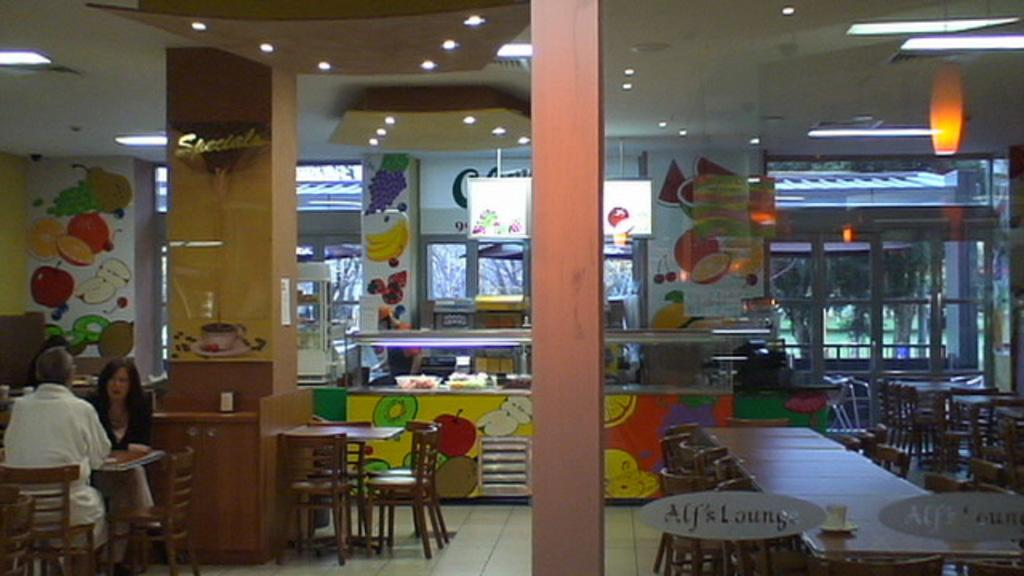How many people are sitting in the image? There are two people sitting on chairs in the image. What else can be seen in the image besides the people? There are additional chairs and tables visible in the image. What can be seen in the background of the image? There are lights and trees visible in the background of the image. What type of clouds can be seen in the image? There are no clouds visible in the image. What kind of wood is used to make the chairs in the image? There is no information about the material used to make the chairs in the image. 